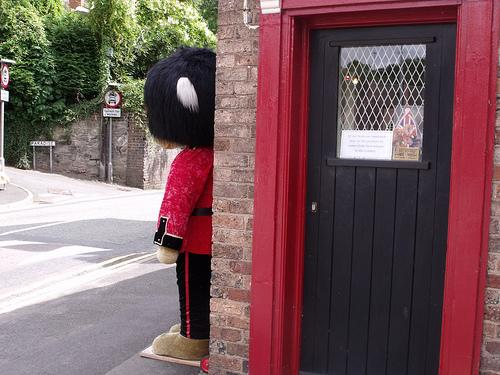Describe the main object's color and any standout features in the image. The central object is a door, primarily black in color with red accents, and featuring a window and a white notice. Briefly describe the central object and its most significant attribute in the image. The primary object is a black and red door with a window, and its most significant attribute is the white notice on it. Mention the most noticeable detail of the primary subject in the image. There is a black door with a red frame that has a window and a white notice on it. State the primary subject of the image and describe its most distinguishing characteristic. The main subject of the image is a black and red door, and its most distinguishing feature is its window with a white notice. In a single sentence, describe the most visually striking aspect of the image. A black and red door with a window and white notice captures the viewer's attention as the main subject of the image. Write a concise description of the main object's appearance and surroundings in the image. The black and red door is the main focus of the image, with its window, white notice, and location on a red frame featured among other surrounding objects. 